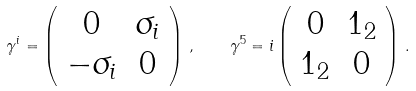<formula> <loc_0><loc_0><loc_500><loc_500>\gamma ^ { i } = \left ( \begin{array} { c c } 0 & \sigma _ { i } \\ - \sigma _ { i } & 0 \end{array} \right ) \, , \quad \gamma ^ { 5 } = i \left ( \begin{array} { c c } 0 & { 1 } _ { 2 } \\ { 1 } _ { 2 } & 0 \end{array} \right ) \, .</formula> 